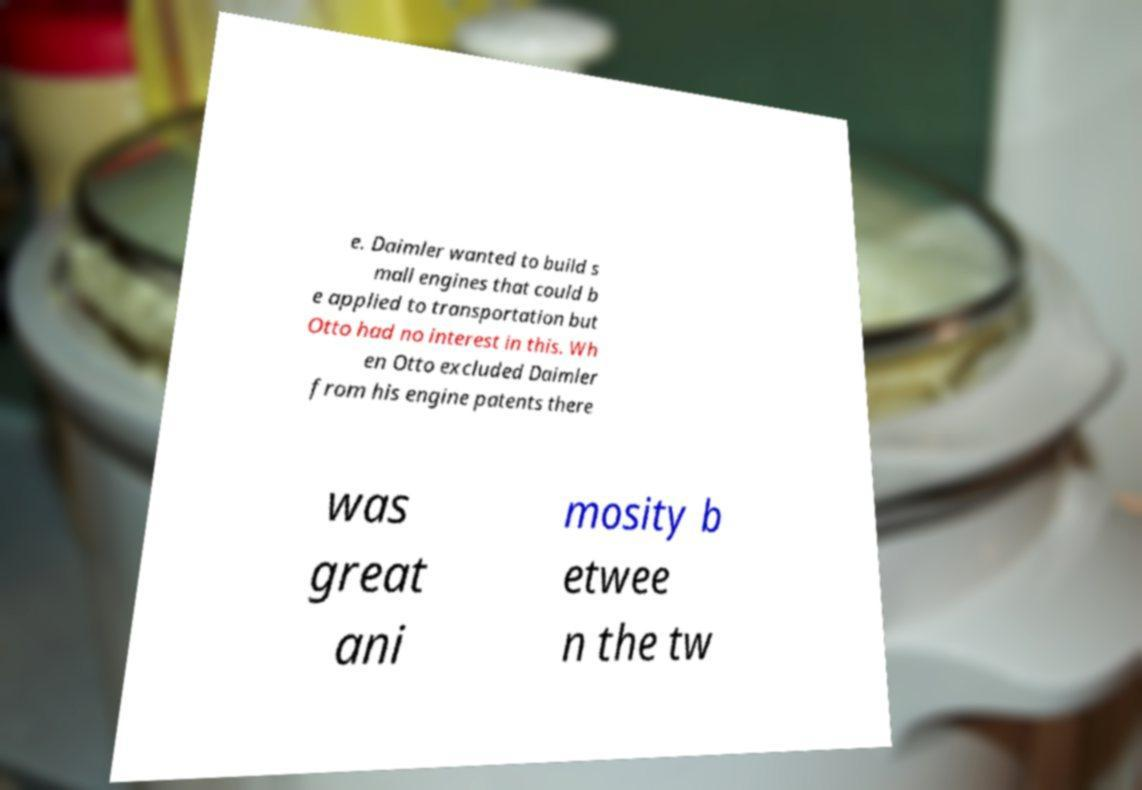I need the written content from this picture converted into text. Can you do that? e. Daimler wanted to build s mall engines that could b e applied to transportation but Otto had no interest in this. Wh en Otto excluded Daimler from his engine patents there was great ani mosity b etwee n the tw 